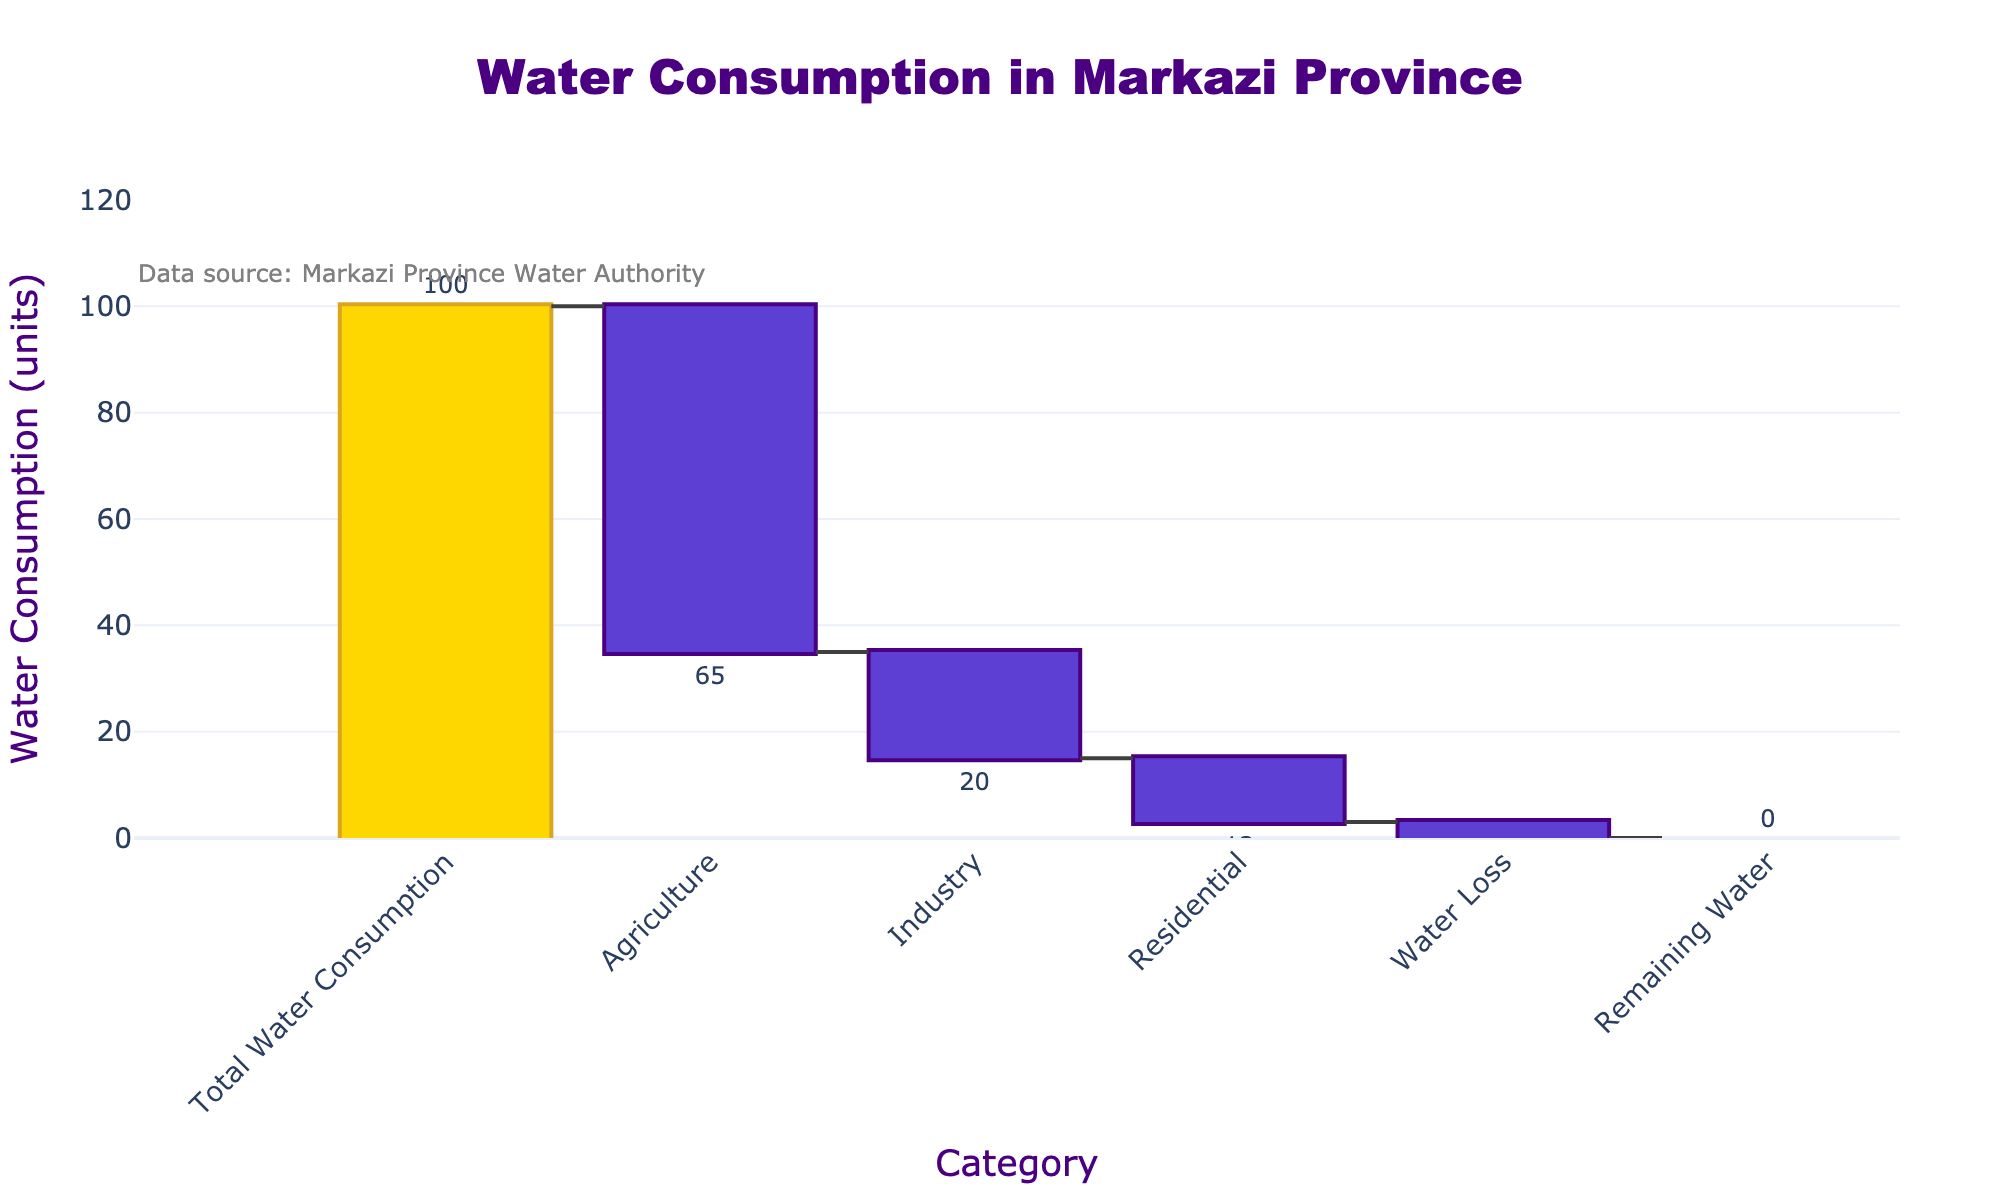What is the title of the plot? The title is located at the top center of the figure and provides a summary of the plotted data. Here, the title should clearly state the main focus of the graph.
Answer: Water Consumption in Markazi Province What is the total water consumption in Markazi province? The initial total water consumption is the first value in the waterfall chart, clearly marked with a numeric value.
Answer: 100 How much water is attributed to agricultural use? Check the segment named 'Agriculture' and read the value next to it. This value represents the water usage for agriculture.
Answer: 65 Which category has the least water consumption? Examine the relative values of the segments in the chart, specifically looking for the smallest negative value between 'Agriculture', 'Industry', 'Residential', and 'Water Loss'.
Answer: Water Loss What is the total water consumption used by industrial and residential sectors combined? Add the values for 'Industry' and 'Residential' together. The industry usage is 20, and the residential usage is 12, so 20 + 12 = 32.
Answer: 32 Compare the water consumption between residential and agricultural uses. Look at the values marked next to 'Residential' and 'Agriculture'. The agriculture value is 65 and the residential value is 12.
Answer: Agricultural use is greater than residential use by 53 How much water remains after all the uses are accounted for? The final value in the waterfall chart reflects the remaining water after subtracting all the uses from the total. This is indicated as 'Remaining Water'.
Answer: 0 What percentage of the total water consumption is used for agriculture? The percentage can be calculated by dividing the agriculture value by the total water consumption and then multiplying by 100. (65 / 100) * 100 = 65%.
Answer: 65% What is the difference in water consumption between industry and agriculture? Subtract the water consumption value of industry from agriculture. The agriculture consumption is 65, and the industry consumption is 20, so 65 - 20 = 45.
Answer: 45 How does the water consumption for residential use compare to industry use? Compare the residential and industry values directly from the chart. Residential use is 12 and industry use is 20.
Answer: Residential use is less than industry use by 8 